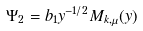Convert formula to latex. <formula><loc_0><loc_0><loc_500><loc_500>\Psi _ { 2 } = b _ { 1 } y ^ { - 1 / 2 } M _ { k , \mu } ( y )</formula> 